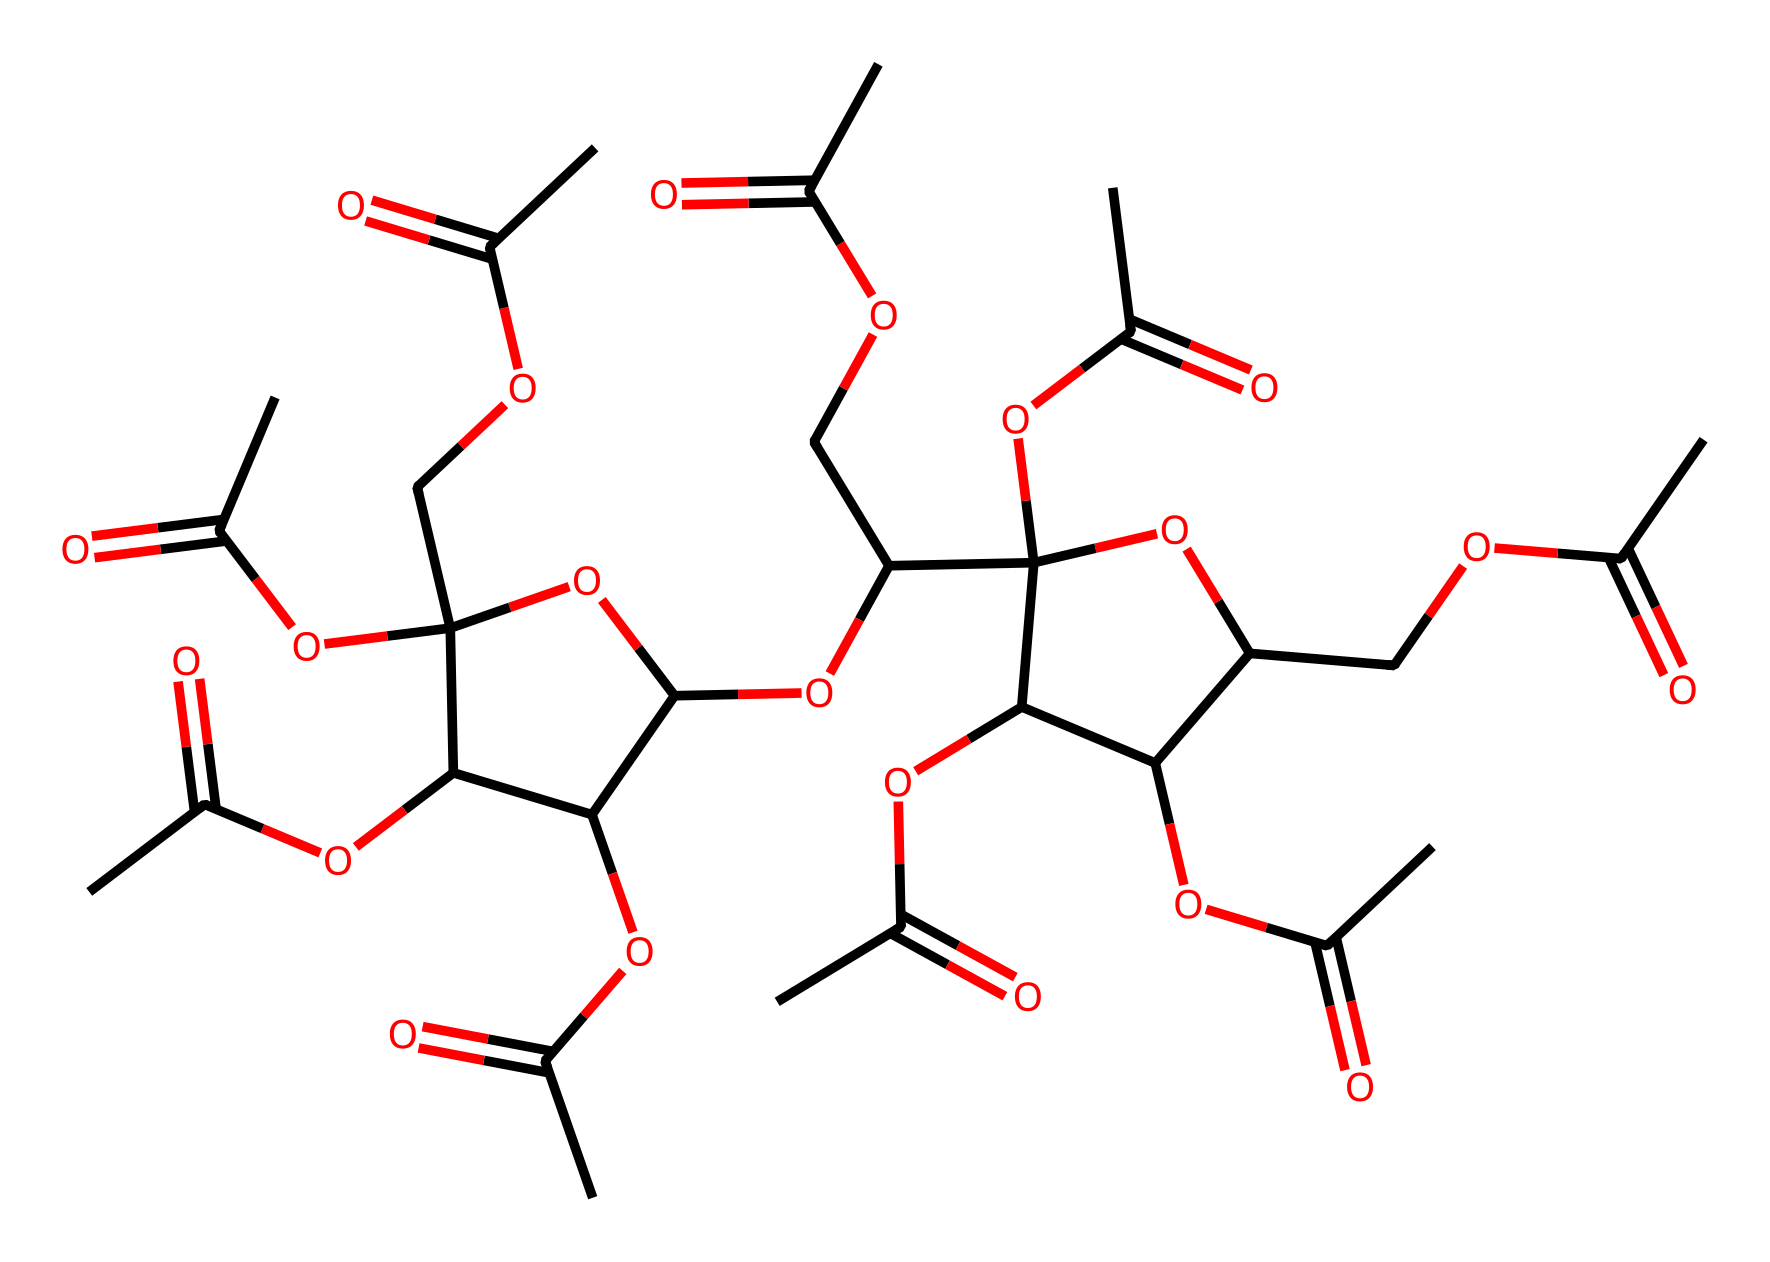What is the molecular formula of cellulose acetate? To determine the molecular formula, we analyze the provided SMILES representation. By counting the carbon (C), hydrogen (H), and oxygen (O) atoms represented in the structure, we can derive the molecular formula. In this case, the structure comprises 9 carbon atoms, 14 hydrogen atoms, and 6 oxygen atoms. The combined count gives us the formula C9H14O6.
Answer: C9H14O6 How many acetyl groups are present in cellulose acetate? An acetyl group (CH3C(=O)) is identifiable in the chemical structure as it has a characteristic ester representation (shown in the SMILES being repeated). By counting these acetyl groups within the structure, we find that there are 5 acetyl groups linked to the cellulose backbone.
Answer: 5 What type of chemical is cellulose acetate classified as? Cellulose acetate, as derived from cellulose, is classified as a non-electrolyte due to its inability to dissociate into ions in solution. Being insoluble in water, it maintains its integrity without forming charged particles when in solvent. This characterization is supported by its structure which lacks ionic bonds.
Answer: non-electrolyte What kind of functional groups are present in cellulose acetate? The main functional groups present in cellulose acetate can be identified through the SMILES representation. They primarily include ester groups, which arise from the acetylation of hydroxyl groups in cellulose. The presence of these ester linkages confirms that cellulose acetate features ester functional groups.
Answer: ester groups How many cyclic structures are observable in the chemical? In examining the SMILES structure, we can identify two distinct cyclic ether structures, indicated by the "C1" and "C2" notations, which signify the start and end of two rings in the structure. Thus, after counting both cyclic components, we find a total of 2 cyclic structures present.
Answer: 2 